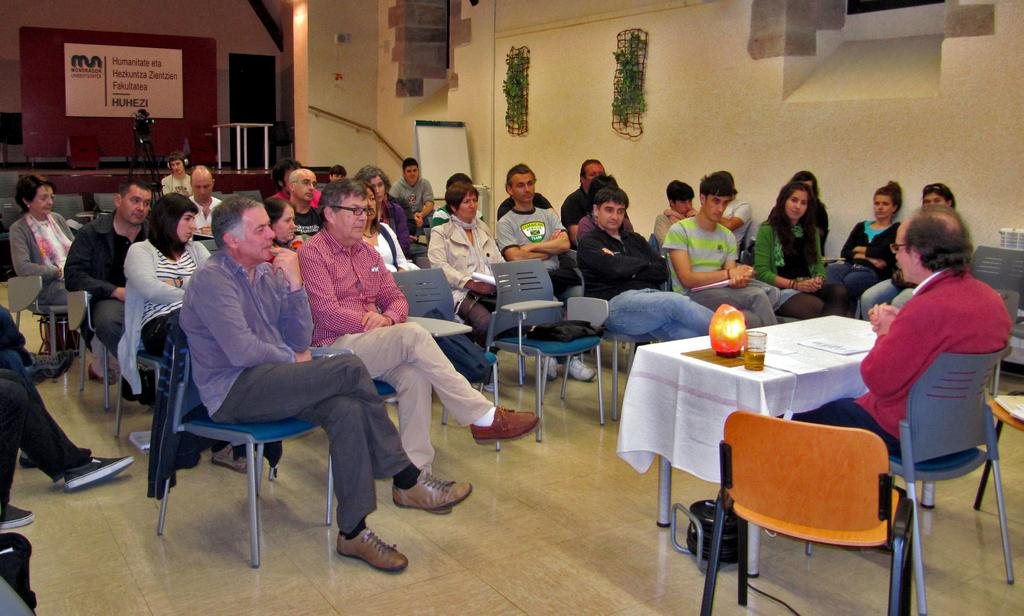What color is the wall in the image? The wall in the image is yellow. What can be seen hanging on the wall? There is a banner in the image. What are the people in the image doing? The people are sitting on chairs in the image. What is on the table in the image? There is a glass and papers on the table in the image. What type of goldfish can be seen swimming in the glass on the table? There is no goldfish present in the image; there is only a glass on the table. 